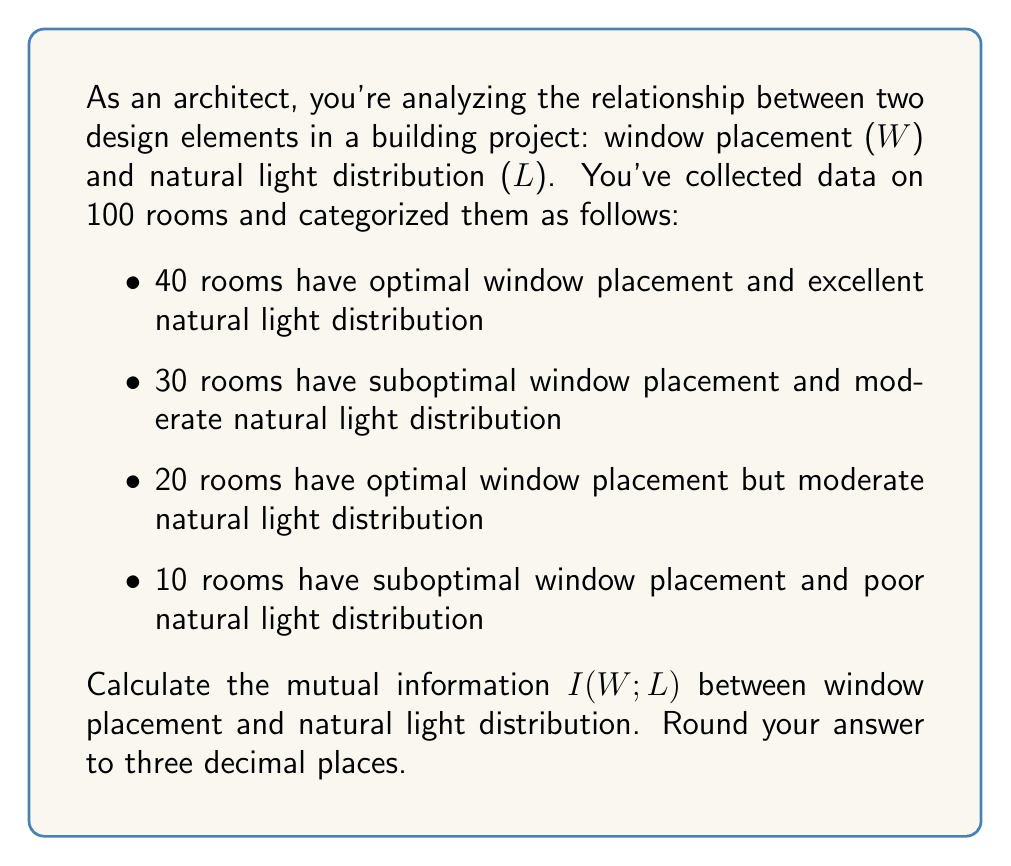Show me your answer to this math problem. To calculate the mutual information between window placement (W) and natural light distribution (L), we'll follow these steps:

1) First, we need to calculate the probabilities:

   $P(W_{optimal}) = (40 + 20) / 100 = 0.6$
   $P(W_{suboptimal}) = (30 + 10) / 100 = 0.4$
   
   $P(L_{excellent}) = 40 / 100 = 0.4$
   $P(L_{moderate}) = (30 + 20) / 100 = 0.5$
   $P(L_{poor}) = 10 / 100 = 0.1$
   
   $P(W_{optimal}, L_{excellent}) = 40 / 100 = 0.4$
   $P(W_{optimal}, L_{moderate}) = 20 / 100 = 0.2$
   $P(W_{optimal}, L_{poor}) = 0 / 100 = 0$
   $P(W_{suboptimal}, L_{excellent}) = 0 / 100 = 0$
   $P(W_{suboptimal}, L_{moderate}) = 30 / 100 = 0.3$
   $P(W_{suboptimal}, L_{poor}) = 10 / 100 = 0.1$

2) The mutual information is given by:

   $$I(W;L) = \sum_{w \in W} \sum_{l \in L} P(w,l) \log_2 \frac{P(w,l)}{P(w)P(l)}$$

3) Let's calculate each term:

   $0.4 \log_2 \frac{0.4}{0.6 \cdot 0.4} = 0.4 \log_2 1.6667 = 0.2370$
   $0.2 \log_2 \frac{0.2}{0.6 \cdot 0.5} = 0.2 \log_2 0.6667 = -0.1188$
   $0 \log_2 \frac{0}{0.6 \cdot 0.1} = 0$ (by convention, $0 \log 0 = 0$)
   $0 \log_2 \frac{0}{0.4 \cdot 0.4} = 0$
   $0.3 \log_2 \frac{0.3}{0.4 \cdot 0.5} = 0.3 \log_2 1.5 = 0.1699$
   $0.1 \log_2 \frac{0.1}{0.4 \cdot 0.1} = 0.1 \log_2 2.5 = 0.1322$

4) Sum all these terms:

   $I(W;L) = 0.2370 - 0.1188 + 0 + 0 + 0.1699 + 0.1322 = 0.4203$

5) Rounding to three decimal places:

   $I(W;L) \approx 0.420$ bits
Answer: 0.420 bits 